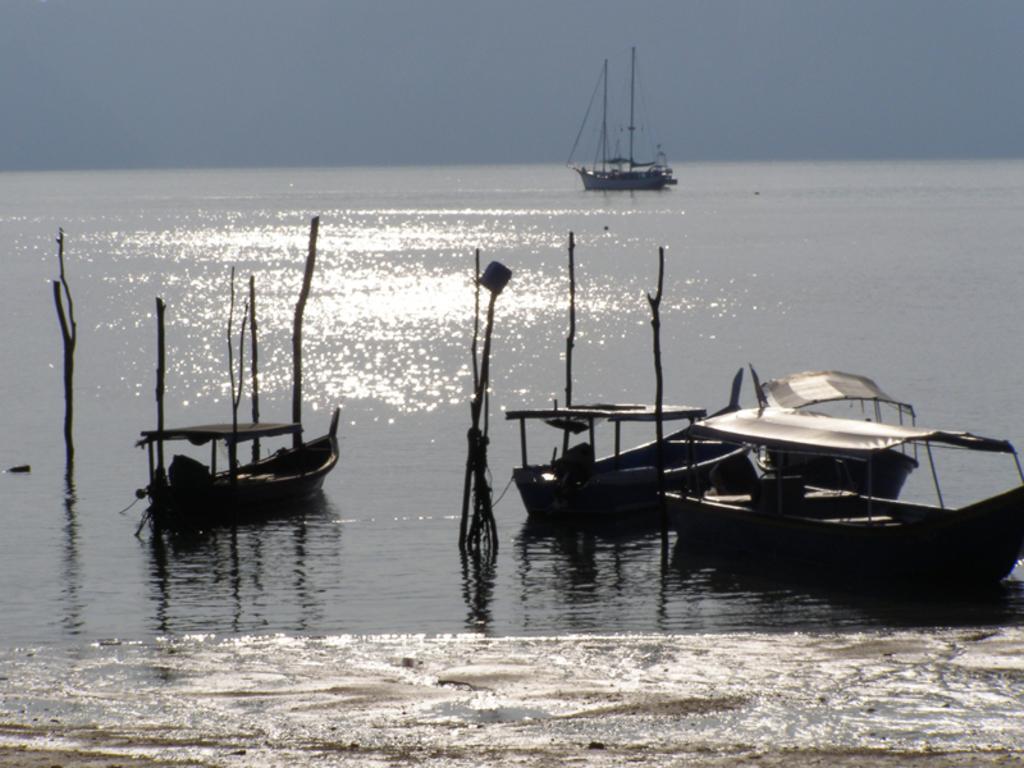How would you summarize this image in a sentence or two? In the center of the image we can see a few boats on the water. And we can see a few poles in the water. At the bottom of the image, we can see some cream color object in the water. In the background we can see the sky, one boat, water etc. 